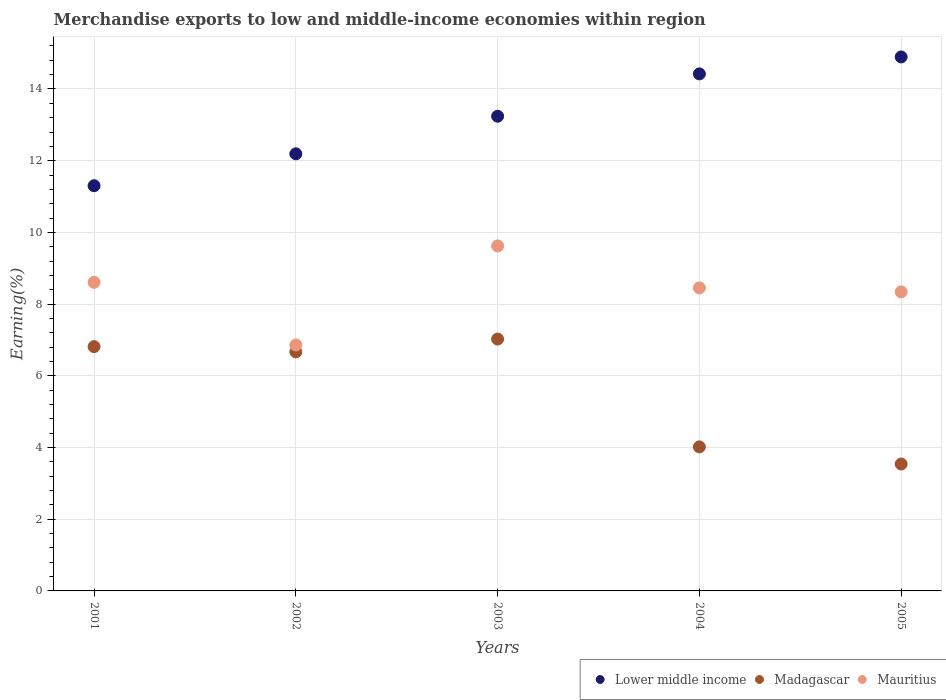Is the number of dotlines equal to the number of legend labels?
Provide a short and direct response. Yes. What is the percentage of amount earned from merchandise exports in Madagascar in 2005?
Make the answer very short. 3.54. Across all years, what is the maximum percentage of amount earned from merchandise exports in Madagascar?
Offer a terse response. 7.02. Across all years, what is the minimum percentage of amount earned from merchandise exports in Mauritius?
Give a very brief answer. 6.86. In which year was the percentage of amount earned from merchandise exports in Madagascar maximum?
Your answer should be compact. 2003. What is the total percentage of amount earned from merchandise exports in Madagascar in the graph?
Keep it short and to the point. 28.06. What is the difference between the percentage of amount earned from merchandise exports in Lower middle income in 2003 and that in 2004?
Provide a succinct answer. -1.18. What is the difference between the percentage of amount earned from merchandise exports in Madagascar in 2003 and the percentage of amount earned from merchandise exports in Lower middle income in 2001?
Ensure brevity in your answer.  -4.28. What is the average percentage of amount earned from merchandise exports in Mauritius per year?
Give a very brief answer. 8.38. In the year 2004, what is the difference between the percentage of amount earned from merchandise exports in Madagascar and percentage of amount earned from merchandise exports in Mauritius?
Offer a terse response. -4.44. In how many years, is the percentage of amount earned from merchandise exports in Mauritius greater than 1.6 %?
Offer a terse response. 5. What is the ratio of the percentage of amount earned from merchandise exports in Mauritius in 2003 to that in 2005?
Provide a short and direct response. 1.15. What is the difference between the highest and the second highest percentage of amount earned from merchandise exports in Madagascar?
Offer a terse response. 0.21. What is the difference between the highest and the lowest percentage of amount earned from merchandise exports in Madagascar?
Your response must be concise. 3.48. In how many years, is the percentage of amount earned from merchandise exports in Lower middle income greater than the average percentage of amount earned from merchandise exports in Lower middle income taken over all years?
Offer a terse response. 3. Is the sum of the percentage of amount earned from merchandise exports in Madagascar in 2001 and 2002 greater than the maximum percentage of amount earned from merchandise exports in Mauritius across all years?
Offer a very short reply. Yes. Is the percentage of amount earned from merchandise exports in Lower middle income strictly greater than the percentage of amount earned from merchandise exports in Mauritius over the years?
Make the answer very short. Yes. Is the percentage of amount earned from merchandise exports in Madagascar strictly less than the percentage of amount earned from merchandise exports in Lower middle income over the years?
Keep it short and to the point. Yes. Are the values on the major ticks of Y-axis written in scientific E-notation?
Provide a succinct answer. No. Does the graph contain any zero values?
Make the answer very short. No. Does the graph contain grids?
Your answer should be very brief. Yes. Where does the legend appear in the graph?
Offer a terse response. Bottom right. How are the legend labels stacked?
Ensure brevity in your answer.  Horizontal. What is the title of the graph?
Provide a succinct answer. Merchandise exports to low and middle-income economies within region. What is the label or title of the Y-axis?
Offer a very short reply. Earning(%). What is the Earning(%) of Lower middle income in 2001?
Keep it short and to the point. 11.3. What is the Earning(%) of Madagascar in 2001?
Offer a terse response. 6.81. What is the Earning(%) in Mauritius in 2001?
Make the answer very short. 8.61. What is the Earning(%) in Lower middle income in 2002?
Your response must be concise. 12.19. What is the Earning(%) of Madagascar in 2002?
Ensure brevity in your answer.  6.67. What is the Earning(%) in Mauritius in 2002?
Your answer should be very brief. 6.86. What is the Earning(%) in Lower middle income in 2003?
Provide a short and direct response. 13.24. What is the Earning(%) in Madagascar in 2003?
Make the answer very short. 7.02. What is the Earning(%) in Mauritius in 2003?
Provide a short and direct response. 9.62. What is the Earning(%) in Lower middle income in 2004?
Offer a terse response. 14.42. What is the Earning(%) in Madagascar in 2004?
Offer a terse response. 4.02. What is the Earning(%) in Mauritius in 2004?
Offer a terse response. 8.45. What is the Earning(%) in Lower middle income in 2005?
Provide a short and direct response. 14.89. What is the Earning(%) in Madagascar in 2005?
Provide a succinct answer. 3.54. What is the Earning(%) in Mauritius in 2005?
Your response must be concise. 8.34. Across all years, what is the maximum Earning(%) of Lower middle income?
Your answer should be very brief. 14.89. Across all years, what is the maximum Earning(%) of Madagascar?
Give a very brief answer. 7.02. Across all years, what is the maximum Earning(%) in Mauritius?
Offer a very short reply. 9.62. Across all years, what is the minimum Earning(%) in Lower middle income?
Offer a very short reply. 11.3. Across all years, what is the minimum Earning(%) of Madagascar?
Offer a very short reply. 3.54. Across all years, what is the minimum Earning(%) in Mauritius?
Your answer should be compact. 6.86. What is the total Earning(%) of Lower middle income in the graph?
Make the answer very short. 66.05. What is the total Earning(%) in Madagascar in the graph?
Your answer should be compact. 28.06. What is the total Earning(%) in Mauritius in the graph?
Provide a succinct answer. 41.88. What is the difference between the Earning(%) in Lower middle income in 2001 and that in 2002?
Offer a very short reply. -0.89. What is the difference between the Earning(%) in Madagascar in 2001 and that in 2002?
Provide a short and direct response. 0.15. What is the difference between the Earning(%) of Mauritius in 2001 and that in 2002?
Your answer should be very brief. 1.75. What is the difference between the Earning(%) in Lower middle income in 2001 and that in 2003?
Make the answer very short. -1.94. What is the difference between the Earning(%) in Madagascar in 2001 and that in 2003?
Give a very brief answer. -0.21. What is the difference between the Earning(%) in Mauritius in 2001 and that in 2003?
Provide a succinct answer. -1.02. What is the difference between the Earning(%) in Lower middle income in 2001 and that in 2004?
Offer a very short reply. -3.12. What is the difference between the Earning(%) of Madagascar in 2001 and that in 2004?
Offer a very short reply. 2.8. What is the difference between the Earning(%) of Mauritius in 2001 and that in 2004?
Offer a terse response. 0.15. What is the difference between the Earning(%) in Lower middle income in 2001 and that in 2005?
Give a very brief answer. -3.59. What is the difference between the Earning(%) of Madagascar in 2001 and that in 2005?
Your answer should be compact. 3.27. What is the difference between the Earning(%) of Mauritius in 2001 and that in 2005?
Provide a succinct answer. 0.27. What is the difference between the Earning(%) in Lower middle income in 2002 and that in 2003?
Make the answer very short. -1.05. What is the difference between the Earning(%) in Madagascar in 2002 and that in 2003?
Your response must be concise. -0.36. What is the difference between the Earning(%) of Mauritius in 2002 and that in 2003?
Provide a succinct answer. -2.76. What is the difference between the Earning(%) in Lower middle income in 2002 and that in 2004?
Provide a succinct answer. -2.23. What is the difference between the Earning(%) in Madagascar in 2002 and that in 2004?
Provide a succinct answer. 2.65. What is the difference between the Earning(%) of Mauritius in 2002 and that in 2004?
Make the answer very short. -1.59. What is the difference between the Earning(%) in Lower middle income in 2002 and that in 2005?
Offer a very short reply. -2.7. What is the difference between the Earning(%) of Madagascar in 2002 and that in 2005?
Offer a very short reply. 3.13. What is the difference between the Earning(%) in Mauritius in 2002 and that in 2005?
Give a very brief answer. -1.48. What is the difference between the Earning(%) in Lower middle income in 2003 and that in 2004?
Offer a terse response. -1.18. What is the difference between the Earning(%) of Madagascar in 2003 and that in 2004?
Provide a succinct answer. 3.01. What is the difference between the Earning(%) in Mauritius in 2003 and that in 2004?
Give a very brief answer. 1.17. What is the difference between the Earning(%) of Lower middle income in 2003 and that in 2005?
Offer a very short reply. -1.65. What is the difference between the Earning(%) in Madagascar in 2003 and that in 2005?
Ensure brevity in your answer.  3.48. What is the difference between the Earning(%) of Mauritius in 2003 and that in 2005?
Make the answer very short. 1.28. What is the difference between the Earning(%) in Lower middle income in 2004 and that in 2005?
Ensure brevity in your answer.  -0.47. What is the difference between the Earning(%) in Madagascar in 2004 and that in 2005?
Your answer should be compact. 0.48. What is the difference between the Earning(%) of Mauritius in 2004 and that in 2005?
Give a very brief answer. 0.11. What is the difference between the Earning(%) in Lower middle income in 2001 and the Earning(%) in Madagascar in 2002?
Offer a terse response. 4.63. What is the difference between the Earning(%) in Lower middle income in 2001 and the Earning(%) in Mauritius in 2002?
Your answer should be compact. 4.44. What is the difference between the Earning(%) in Madagascar in 2001 and the Earning(%) in Mauritius in 2002?
Provide a succinct answer. -0.05. What is the difference between the Earning(%) in Lower middle income in 2001 and the Earning(%) in Madagascar in 2003?
Your answer should be compact. 4.28. What is the difference between the Earning(%) in Lower middle income in 2001 and the Earning(%) in Mauritius in 2003?
Provide a succinct answer. 1.68. What is the difference between the Earning(%) of Madagascar in 2001 and the Earning(%) of Mauritius in 2003?
Give a very brief answer. -2.81. What is the difference between the Earning(%) in Lower middle income in 2001 and the Earning(%) in Madagascar in 2004?
Provide a short and direct response. 7.28. What is the difference between the Earning(%) in Lower middle income in 2001 and the Earning(%) in Mauritius in 2004?
Provide a succinct answer. 2.85. What is the difference between the Earning(%) of Madagascar in 2001 and the Earning(%) of Mauritius in 2004?
Offer a terse response. -1.64. What is the difference between the Earning(%) in Lower middle income in 2001 and the Earning(%) in Madagascar in 2005?
Your answer should be compact. 7.76. What is the difference between the Earning(%) of Lower middle income in 2001 and the Earning(%) of Mauritius in 2005?
Keep it short and to the point. 2.96. What is the difference between the Earning(%) in Madagascar in 2001 and the Earning(%) in Mauritius in 2005?
Your answer should be very brief. -1.53. What is the difference between the Earning(%) of Lower middle income in 2002 and the Earning(%) of Madagascar in 2003?
Your answer should be compact. 5.17. What is the difference between the Earning(%) in Lower middle income in 2002 and the Earning(%) in Mauritius in 2003?
Your answer should be very brief. 2.57. What is the difference between the Earning(%) in Madagascar in 2002 and the Earning(%) in Mauritius in 2003?
Your answer should be compact. -2.95. What is the difference between the Earning(%) of Lower middle income in 2002 and the Earning(%) of Madagascar in 2004?
Provide a short and direct response. 8.17. What is the difference between the Earning(%) in Lower middle income in 2002 and the Earning(%) in Mauritius in 2004?
Your answer should be compact. 3.74. What is the difference between the Earning(%) in Madagascar in 2002 and the Earning(%) in Mauritius in 2004?
Offer a terse response. -1.78. What is the difference between the Earning(%) of Lower middle income in 2002 and the Earning(%) of Madagascar in 2005?
Your answer should be very brief. 8.65. What is the difference between the Earning(%) of Lower middle income in 2002 and the Earning(%) of Mauritius in 2005?
Ensure brevity in your answer.  3.85. What is the difference between the Earning(%) in Madagascar in 2002 and the Earning(%) in Mauritius in 2005?
Provide a short and direct response. -1.67. What is the difference between the Earning(%) in Lower middle income in 2003 and the Earning(%) in Madagascar in 2004?
Provide a short and direct response. 9.22. What is the difference between the Earning(%) in Lower middle income in 2003 and the Earning(%) in Mauritius in 2004?
Your answer should be compact. 4.79. What is the difference between the Earning(%) of Madagascar in 2003 and the Earning(%) of Mauritius in 2004?
Offer a terse response. -1.43. What is the difference between the Earning(%) of Lower middle income in 2003 and the Earning(%) of Madagascar in 2005?
Provide a succinct answer. 9.7. What is the difference between the Earning(%) in Lower middle income in 2003 and the Earning(%) in Mauritius in 2005?
Your response must be concise. 4.9. What is the difference between the Earning(%) of Madagascar in 2003 and the Earning(%) of Mauritius in 2005?
Your answer should be very brief. -1.32. What is the difference between the Earning(%) in Lower middle income in 2004 and the Earning(%) in Madagascar in 2005?
Your answer should be compact. 10.88. What is the difference between the Earning(%) in Lower middle income in 2004 and the Earning(%) in Mauritius in 2005?
Provide a short and direct response. 6.08. What is the difference between the Earning(%) of Madagascar in 2004 and the Earning(%) of Mauritius in 2005?
Provide a succinct answer. -4.32. What is the average Earning(%) of Lower middle income per year?
Provide a succinct answer. 13.21. What is the average Earning(%) of Madagascar per year?
Your answer should be very brief. 5.61. What is the average Earning(%) of Mauritius per year?
Your answer should be very brief. 8.38. In the year 2001, what is the difference between the Earning(%) in Lower middle income and Earning(%) in Madagascar?
Your response must be concise. 4.49. In the year 2001, what is the difference between the Earning(%) in Lower middle income and Earning(%) in Mauritius?
Keep it short and to the point. 2.7. In the year 2001, what is the difference between the Earning(%) of Madagascar and Earning(%) of Mauritius?
Your answer should be compact. -1.79. In the year 2002, what is the difference between the Earning(%) in Lower middle income and Earning(%) in Madagascar?
Your response must be concise. 5.52. In the year 2002, what is the difference between the Earning(%) in Lower middle income and Earning(%) in Mauritius?
Offer a terse response. 5.33. In the year 2002, what is the difference between the Earning(%) of Madagascar and Earning(%) of Mauritius?
Provide a short and direct response. -0.19. In the year 2003, what is the difference between the Earning(%) of Lower middle income and Earning(%) of Madagascar?
Offer a terse response. 6.22. In the year 2003, what is the difference between the Earning(%) in Lower middle income and Earning(%) in Mauritius?
Your answer should be very brief. 3.62. In the year 2003, what is the difference between the Earning(%) in Madagascar and Earning(%) in Mauritius?
Your response must be concise. -2.6. In the year 2004, what is the difference between the Earning(%) in Lower middle income and Earning(%) in Madagascar?
Offer a very short reply. 10.4. In the year 2004, what is the difference between the Earning(%) in Lower middle income and Earning(%) in Mauritius?
Keep it short and to the point. 5.97. In the year 2004, what is the difference between the Earning(%) in Madagascar and Earning(%) in Mauritius?
Your answer should be compact. -4.44. In the year 2005, what is the difference between the Earning(%) of Lower middle income and Earning(%) of Madagascar?
Your answer should be compact. 11.35. In the year 2005, what is the difference between the Earning(%) in Lower middle income and Earning(%) in Mauritius?
Provide a short and direct response. 6.55. In the year 2005, what is the difference between the Earning(%) of Madagascar and Earning(%) of Mauritius?
Provide a short and direct response. -4.8. What is the ratio of the Earning(%) of Lower middle income in 2001 to that in 2002?
Make the answer very short. 0.93. What is the ratio of the Earning(%) in Madagascar in 2001 to that in 2002?
Offer a terse response. 1.02. What is the ratio of the Earning(%) of Mauritius in 2001 to that in 2002?
Provide a short and direct response. 1.25. What is the ratio of the Earning(%) of Lower middle income in 2001 to that in 2003?
Provide a short and direct response. 0.85. What is the ratio of the Earning(%) of Madagascar in 2001 to that in 2003?
Provide a succinct answer. 0.97. What is the ratio of the Earning(%) of Mauritius in 2001 to that in 2003?
Ensure brevity in your answer.  0.89. What is the ratio of the Earning(%) in Lower middle income in 2001 to that in 2004?
Offer a terse response. 0.78. What is the ratio of the Earning(%) in Madagascar in 2001 to that in 2004?
Offer a very short reply. 1.7. What is the ratio of the Earning(%) of Mauritius in 2001 to that in 2004?
Provide a short and direct response. 1.02. What is the ratio of the Earning(%) of Lower middle income in 2001 to that in 2005?
Keep it short and to the point. 0.76. What is the ratio of the Earning(%) of Madagascar in 2001 to that in 2005?
Provide a short and direct response. 1.92. What is the ratio of the Earning(%) in Mauritius in 2001 to that in 2005?
Provide a short and direct response. 1.03. What is the ratio of the Earning(%) of Lower middle income in 2002 to that in 2003?
Offer a very short reply. 0.92. What is the ratio of the Earning(%) in Madagascar in 2002 to that in 2003?
Make the answer very short. 0.95. What is the ratio of the Earning(%) of Mauritius in 2002 to that in 2003?
Offer a very short reply. 0.71. What is the ratio of the Earning(%) in Lower middle income in 2002 to that in 2004?
Your answer should be very brief. 0.85. What is the ratio of the Earning(%) in Madagascar in 2002 to that in 2004?
Keep it short and to the point. 1.66. What is the ratio of the Earning(%) of Mauritius in 2002 to that in 2004?
Give a very brief answer. 0.81. What is the ratio of the Earning(%) in Lower middle income in 2002 to that in 2005?
Make the answer very short. 0.82. What is the ratio of the Earning(%) in Madagascar in 2002 to that in 2005?
Ensure brevity in your answer.  1.88. What is the ratio of the Earning(%) of Mauritius in 2002 to that in 2005?
Provide a succinct answer. 0.82. What is the ratio of the Earning(%) of Lower middle income in 2003 to that in 2004?
Provide a short and direct response. 0.92. What is the ratio of the Earning(%) in Madagascar in 2003 to that in 2004?
Ensure brevity in your answer.  1.75. What is the ratio of the Earning(%) in Mauritius in 2003 to that in 2004?
Give a very brief answer. 1.14. What is the ratio of the Earning(%) of Madagascar in 2003 to that in 2005?
Offer a very short reply. 1.98. What is the ratio of the Earning(%) of Mauritius in 2003 to that in 2005?
Your answer should be compact. 1.15. What is the ratio of the Earning(%) in Lower middle income in 2004 to that in 2005?
Make the answer very short. 0.97. What is the ratio of the Earning(%) in Madagascar in 2004 to that in 2005?
Offer a terse response. 1.13. What is the ratio of the Earning(%) in Mauritius in 2004 to that in 2005?
Provide a short and direct response. 1.01. What is the difference between the highest and the second highest Earning(%) of Lower middle income?
Provide a short and direct response. 0.47. What is the difference between the highest and the second highest Earning(%) in Madagascar?
Provide a succinct answer. 0.21. What is the difference between the highest and the second highest Earning(%) of Mauritius?
Provide a short and direct response. 1.02. What is the difference between the highest and the lowest Earning(%) of Lower middle income?
Provide a short and direct response. 3.59. What is the difference between the highest and the lowest Earning(%) of Madagascar?
Keep it short and to the point. 3.48. What is the difference between the highest and the lowest Earning(%) in Mauritius?
Your answer should be very brief. 2.76. 